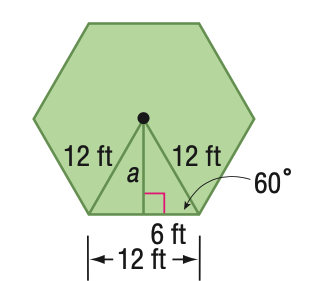Answer the mathemtical geometry problem and directly provide the correct option letter.
Question: Find the area of a regular hexagon with a perimeter of 72 feet.
Choices: A: 187.1 B: 305.5 C: 374.1 D: 532 C 